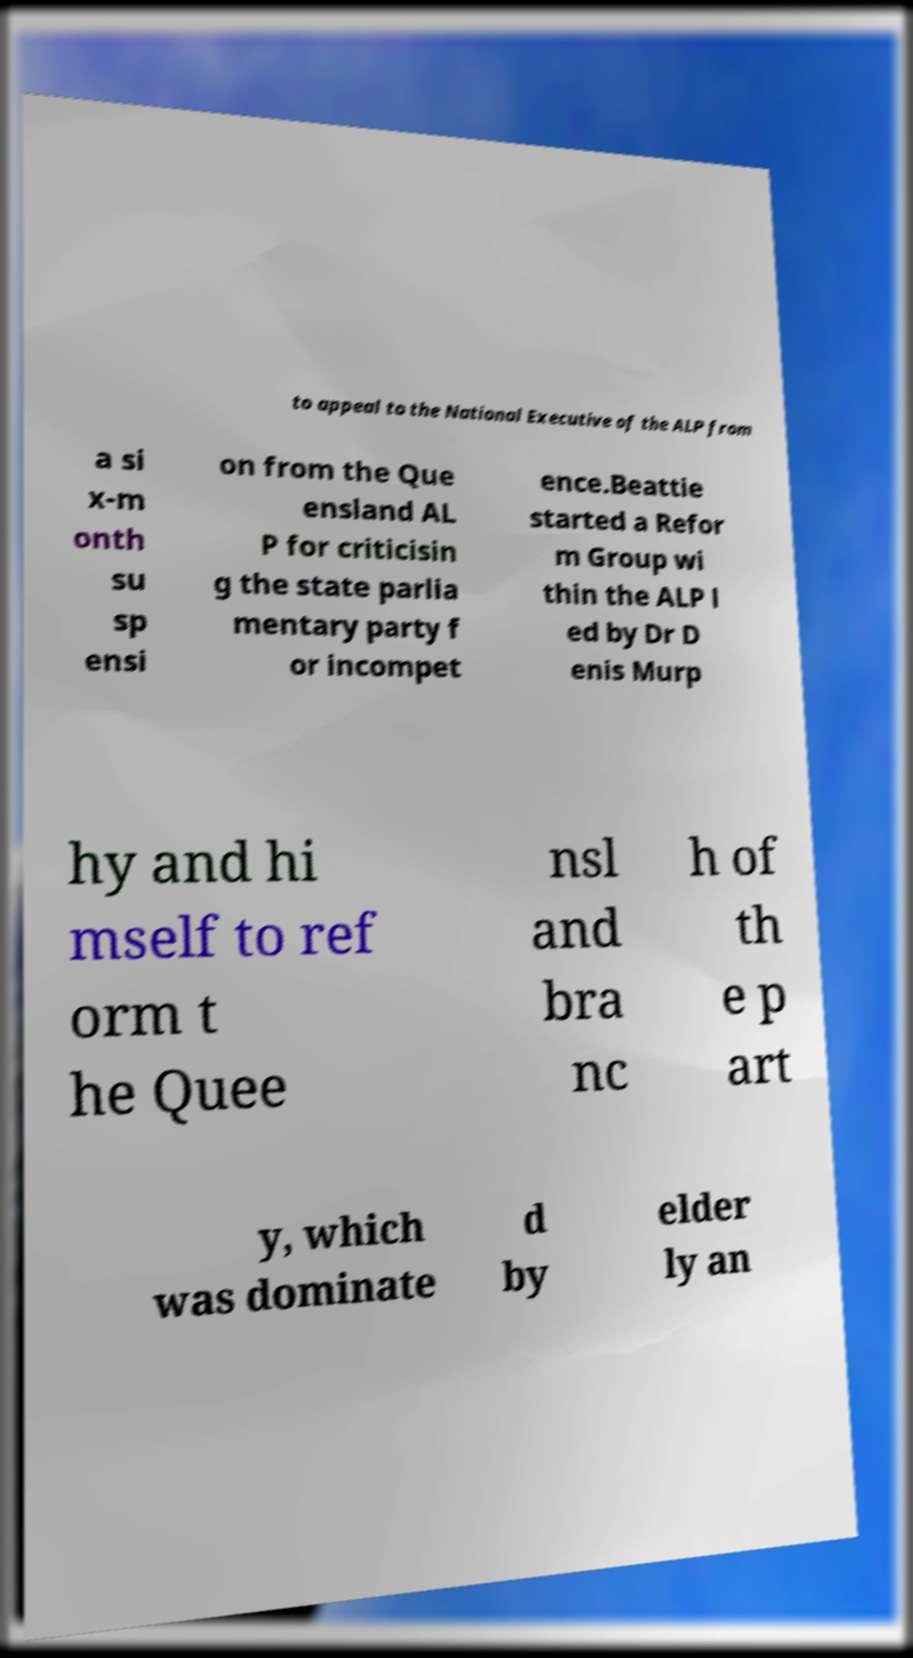Could you assist in decoding the text presented in this image and type it out clearly? to appeal to the National Executive of the ALP from a si x-m onth su sp ensi on from the Que ensland AL P for criticisin g the state parlia mentary party f or incompet ence.Beattie started a Refor m Group wi thin the ALP l ed by Dr D enis Murp hy and hi mself to ref orm t he Quee nsl and bra nc h of th e p art y, which was dominate d by elder ly an 